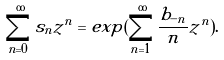<formula> <loc_0><loc_0><loc_500><loc_500>\sum _ { n = 0 } ^ { \infty } s _ { n } z ^ { n } = e x p ( \sum _ { n = 1 } ^ { \infty } \frac { b _ { - n } } { n } z ^ { n } ) .</formula> 